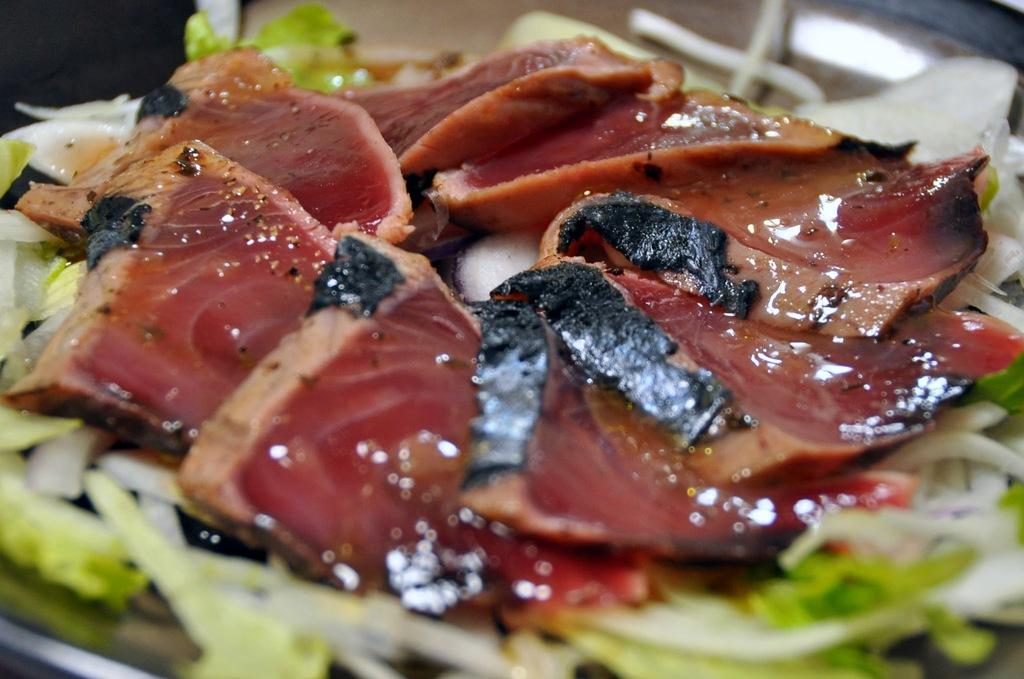What type of food item can be seen in the image? There is a food item in the image, specifically a salad on a platter. Can you describe the presentation of the food item? The salad is on a platter in the image. What type of sand can be seen in the image? There is no sand present in the image; it features a salad on a platter. How many brothers are visible in the image? There are no people, including brothers, present in the image. 